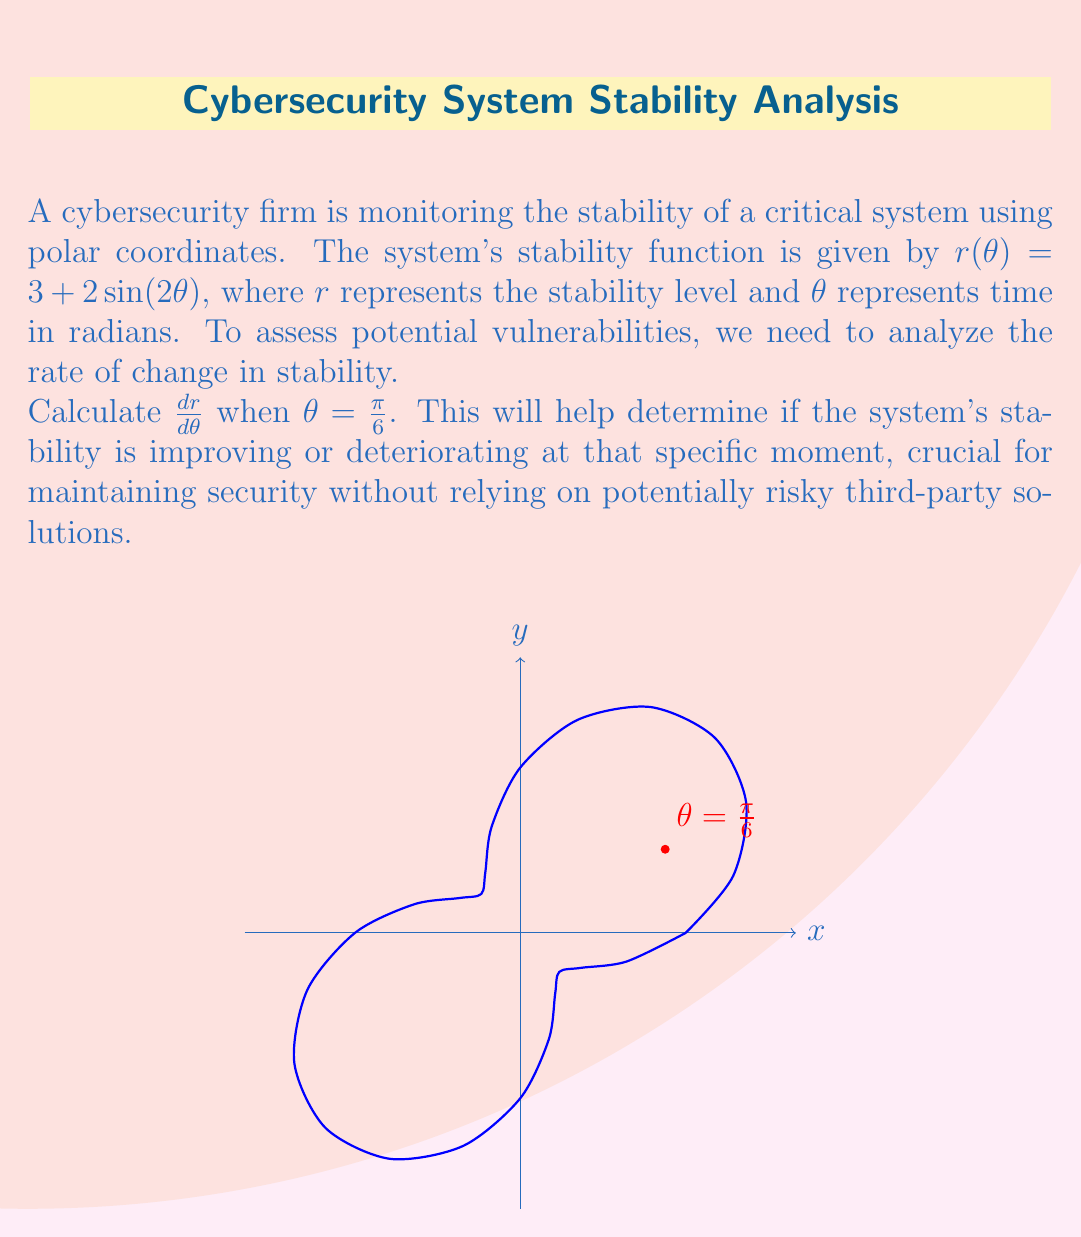Can you answer this question? To solve this problem, we'll follow these steps:

1) First, we need to find the derivative of $r(\theta)$ with respect to $\theta$. 
   
   $r(\theta) = 3 + 2\sin(2\theta)$
   
   Using the chain rule, we get:
   
   $$\frac{dr}{d\theta} = 2 \cdot 2 \cos(2\theta) = 4\cos(2\theta)$$

2) Now that we have the derivative, we need to evaluate it at $\theta = \frac{\pi}{6}$.

   $$\frac{dr}{d\theta}\bigg|_{\theta=\frac{\pi}{6}} = 4\cos(2\cdot\frac{\pi}{6})$$

3) Simplify the argument of cosine:
   
   $$= 4\cos(\frac{\pi}{3})$$

4) Recall that $\cos(\frac{\pi}{3}) = \frac{1}{2}$

   $$= 4 \cdot \frac{1}{2} = 2$$

Therefore, at $\theta = \frac{\pi}{6}$, the rate of change of the system's stability is 2 units per radian.

This positive value indicates that the system's stability is increasing at this moment, which is a good sign for security. However, continuous monitoring is crucial as the rate of change varies with time.
Answer: $2$ 